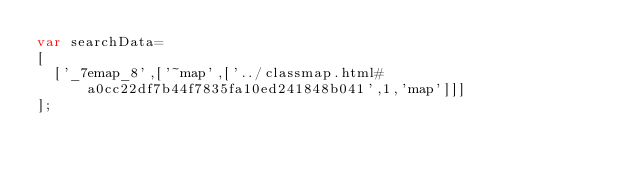Convert code to text. <code><loc_0><loc_0><loc_500><loc_500><_JavaScript_>var searchData=
[
  ['_7emap_8',['~map',['../classmap.html#a0cc22df7b44f7835fa10ed241848b041',1,'map']]]
];
</code> 